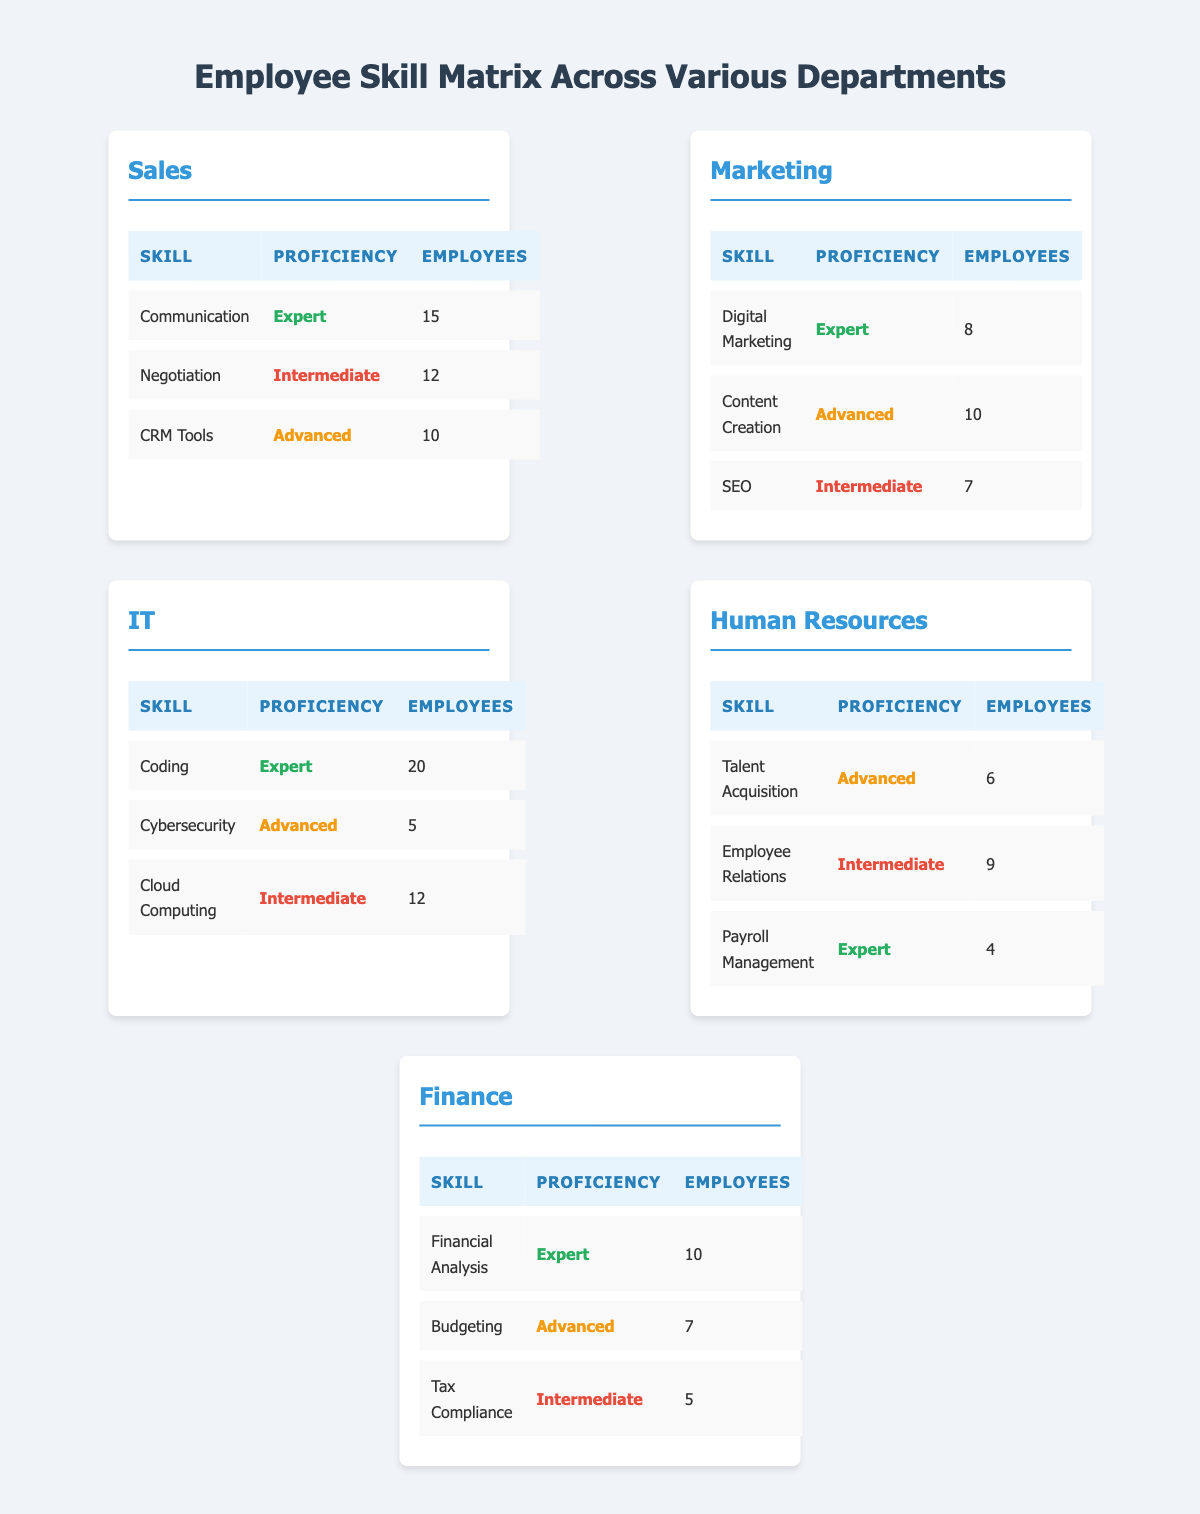What is the highest proficiency level found in the Sales department? By reviewing the skills listed under the Sales department, we find "Communication" with a proficiency level of "Expert" has the highest ranking, as no other skill surpasses "Expert."
Answer: Expert How many employees are proficient in SEO in the Marketing department? The table for the Marketing department indicates that the proficiency level for SEO is "Intermediate," and 7 employees have this skill.
Answer: 7 Which department has the most employees skilled in Coding? In the table under the IT department, "Coding" is noted with 20 employees, which is the highest count among all departments for any skill.
Answer: IT What is the total number of employees proficient in Advanced skills across all departments? Adding the number of employees proficient in Advanced skills: Sales (10) + Marketing (10) + IT (5) + Human Resources (6) + Finance (7) gives a total of 48 employees.
Answer: 48 Is there any department where the number of employees proficient in Intermediate skills exceeds 10? The counts for Intermediate proficiency are: Sales (12), Marketing (7), IT (12), Human Resources (9), and Finance (5). Only Sales and IT have counts above 10. Thus, the answer is yes.
Answer: Yes What is the average number of employees proficient in Expert skills across all departments? The departments with Expert skills are: Sales (15), Marketing (8), IT (20), Human Resources (4), and Finance (10). The total number of employees skilled at this level is 57 (15 + 8 + 20 + 4 + 10), and there are 5 departments, so the average is 57 / 5 = 11.4.
Answer: 11.4 Which skill in the Human Resources department has the least number of employees, and how many? Reviewing the Human Resources department, "Payroll Management" has the least number of employees with a count of 4 while having "Expert" proficiency.
Answer: Payroll Management, 4 What are the total employees across the Marketing department for all skills? By summing the employees in the Marketing department: Digital Marketing (8) + Content Creation (10) + SEO (7) gives a total of 25 employees.
Answer: 25 Are there any employees skilled in Cybersecurity at a level lower than Intermediate? The table shows that the only proficiency for Cybersecurity is "Advanced," meaning there are no employees at a lower level. Thus, the response is no.
Answer: No 